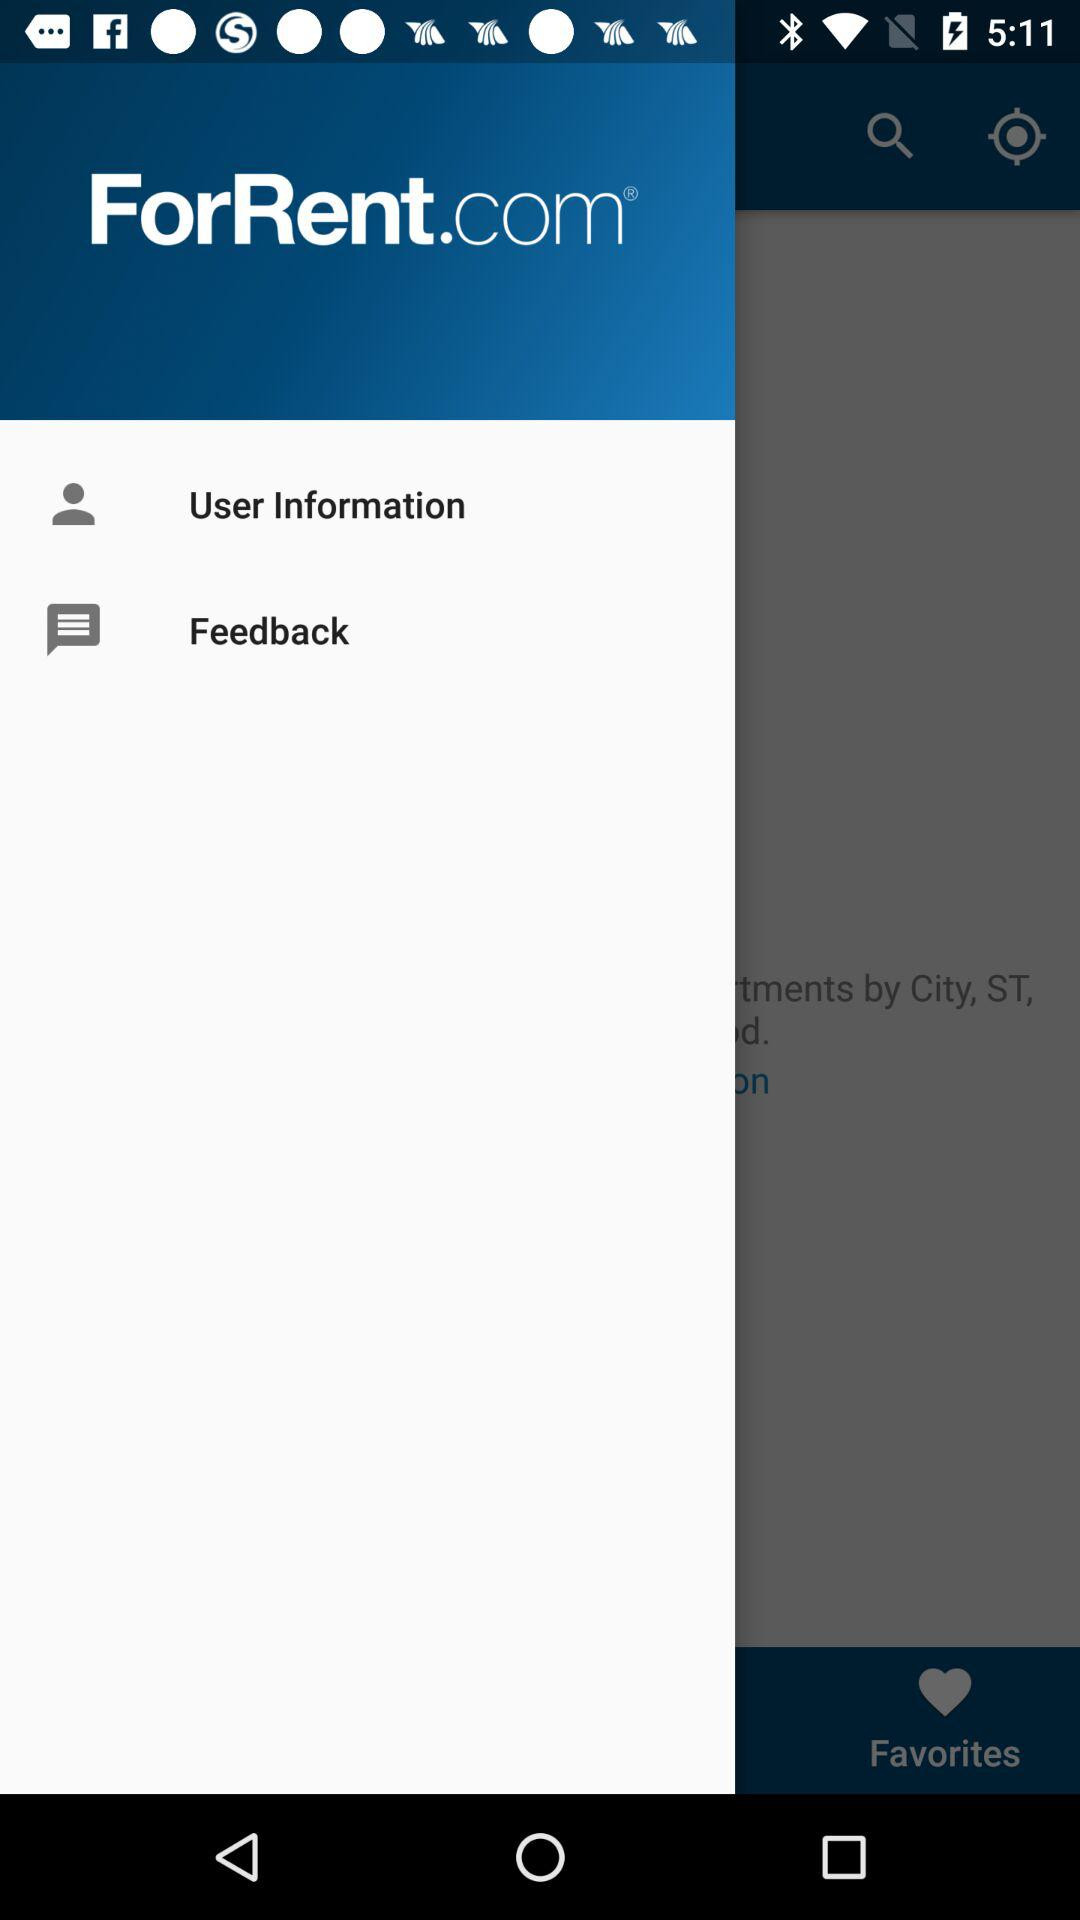How many messages are in Feedback"?
When the provided information is insufficient, respond with <no answer>. <no answer> 